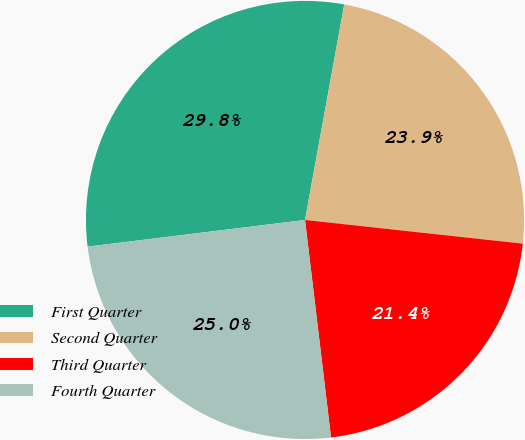Convert chart. <chart><loc_0><loc_0><loc_500><loc_500><pie_chart><fcel>First Quarter<fcel>Second Quarter<fcel>Third Quarter<fcel>Fourth Quarter<nl><fcel>29.81%<fcel>23.86%<fcel>21.38%<fcel>24.95%<nl></chart> 